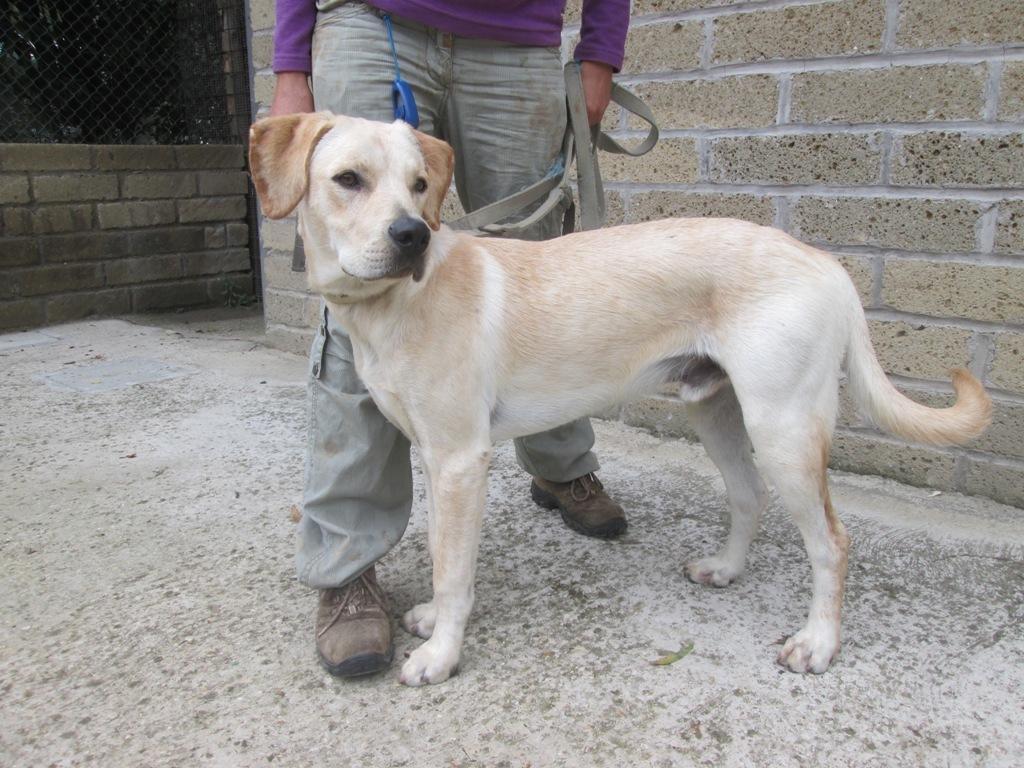Describe this image in one or two sentences. This image consists of a dog in white color. At the bottom, there is a floor. Behind the dog, there is a man standing. In the background, there is a wall. 